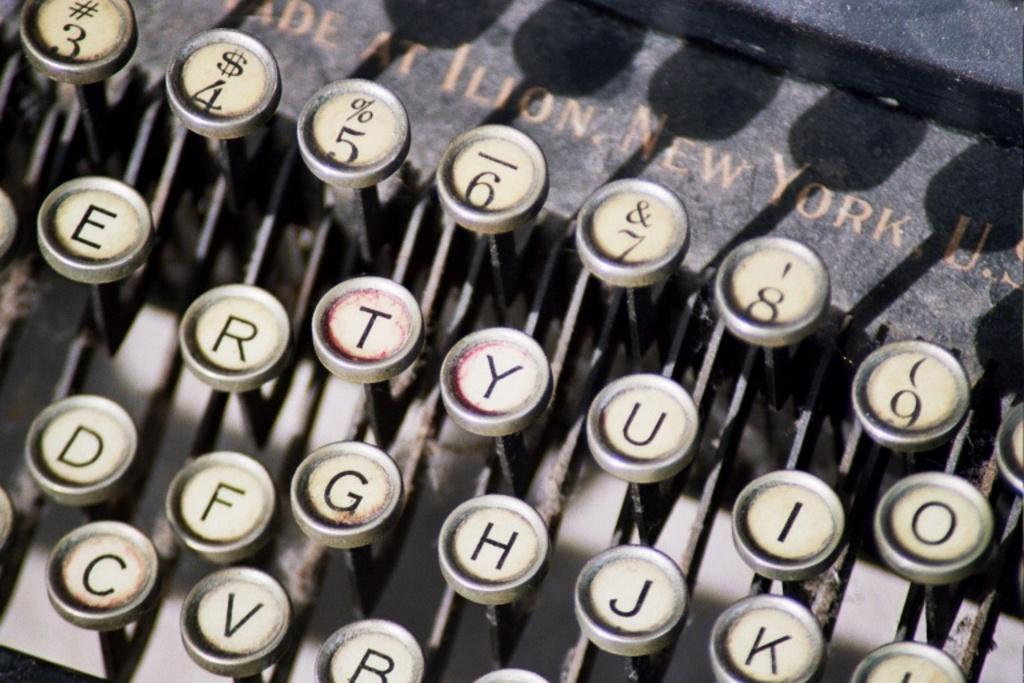<image>
Share a concise interpretation of the image provided. a typewriter that has the words 'new york' above the top keys 